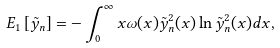<formula> <loc_0><loc_0><loc_500><loc_500>E _ { 1 } \left [ { \tilde { y } } _ { n } \right ] = - \int _ { 0 } ^ { \infty } x \omega ( x ) { \tilde { y } } ^ { 2 } _ { n } ( x ) \ln { \tilde { y } } ^ { 2 } _ { n } ( x ) d x ,</formula> 